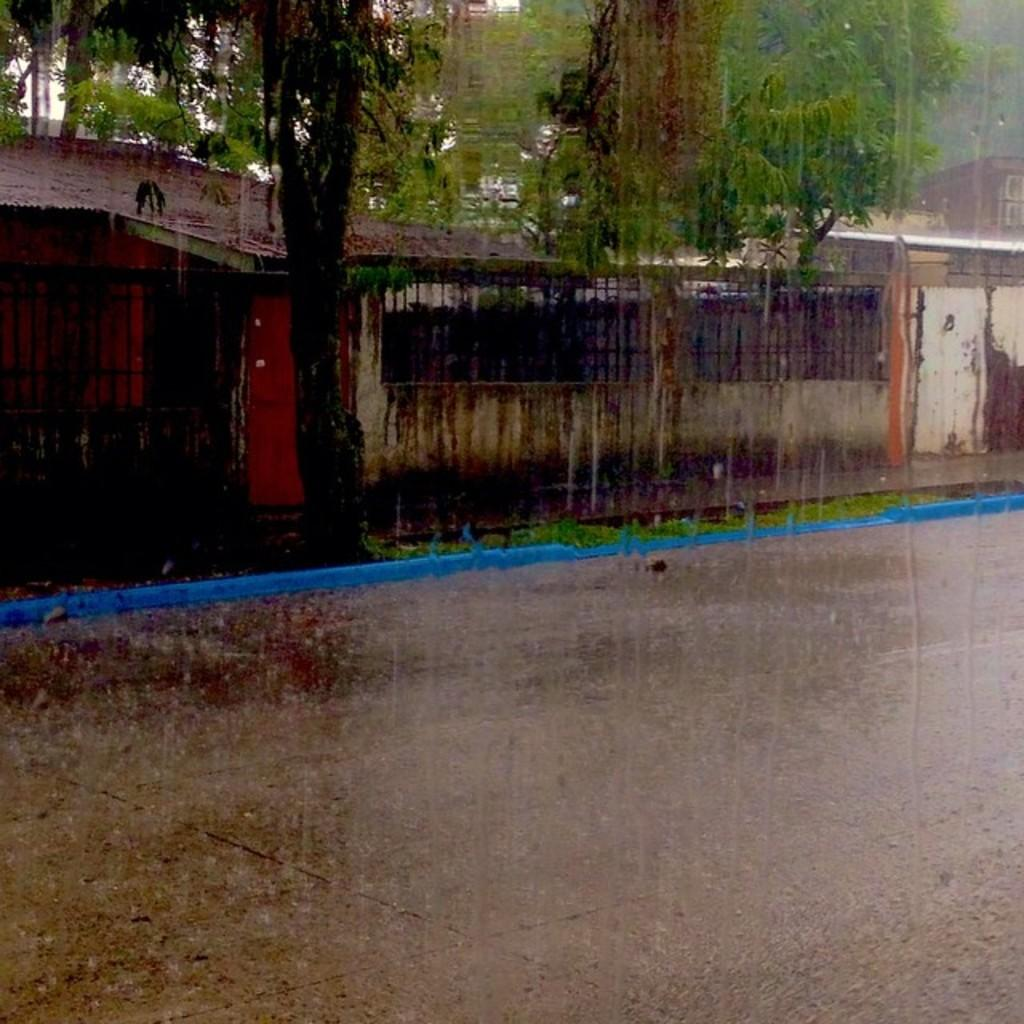What type of environment is depicted in the image? The image is an outside view. What weather condition can be observed in the image? It is raining in the image. What is located at the bottom of the image? There is a road at the bottom of the image. What structures are visible in the background of the image? There are houses and trees in the background of the image. How many babies are visible in the image? There are no babies present in the image. What type of coat is the tree wearing in the image? Trees do not wear coats; they are plants and do not have clothing. 